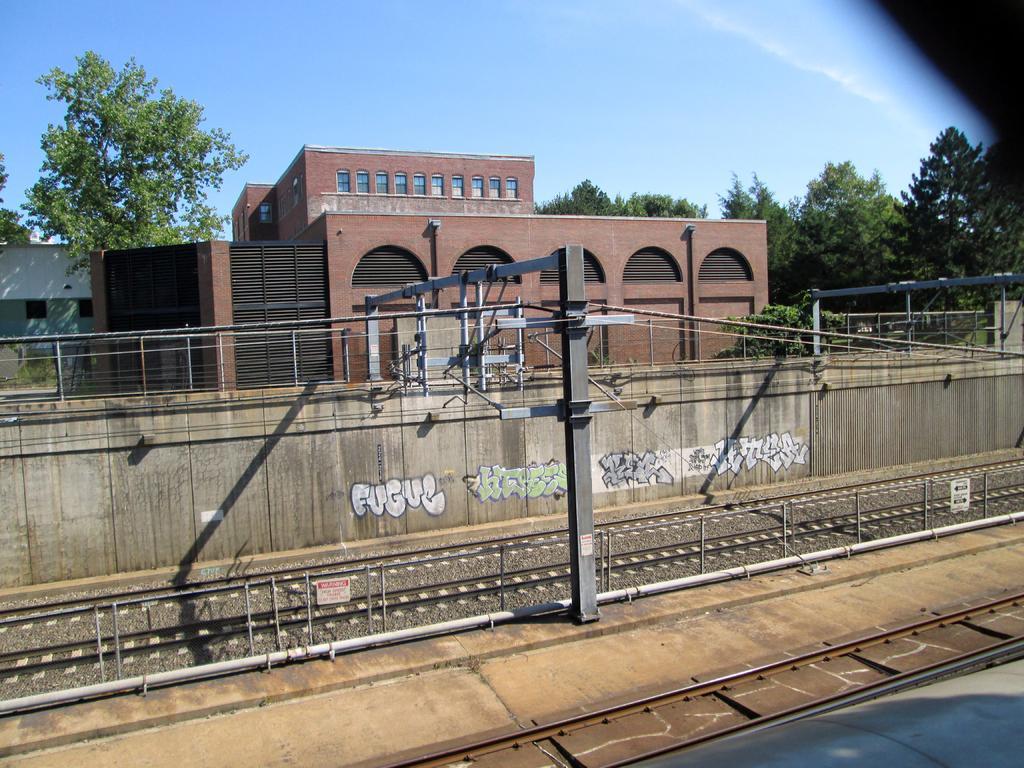Describe this image in one or two sentences. In this image we can see buildings, there are some trees, poles, wires and railway tracks, in the background we can see the sky. 